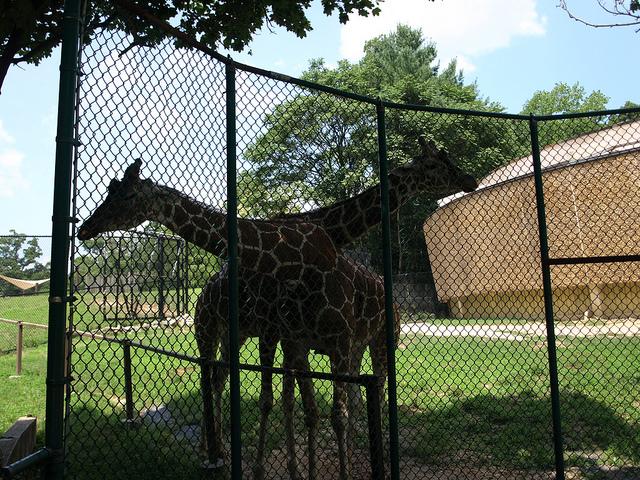What type of animals are these?
Be succinct. Giraffes. Can the giraffes escape and roam free?
Be succinct. No. Are the giraffes taller than their cage?
Be succinct. No. What animals are in the cages?
Be succinct. Giraffes. Does this look like an adult giraffe?
Keep it brief. Yes. How many animals are in the photo?
Short answer required. 2. Are any of the giraffes eating?
Be succinct. No. 